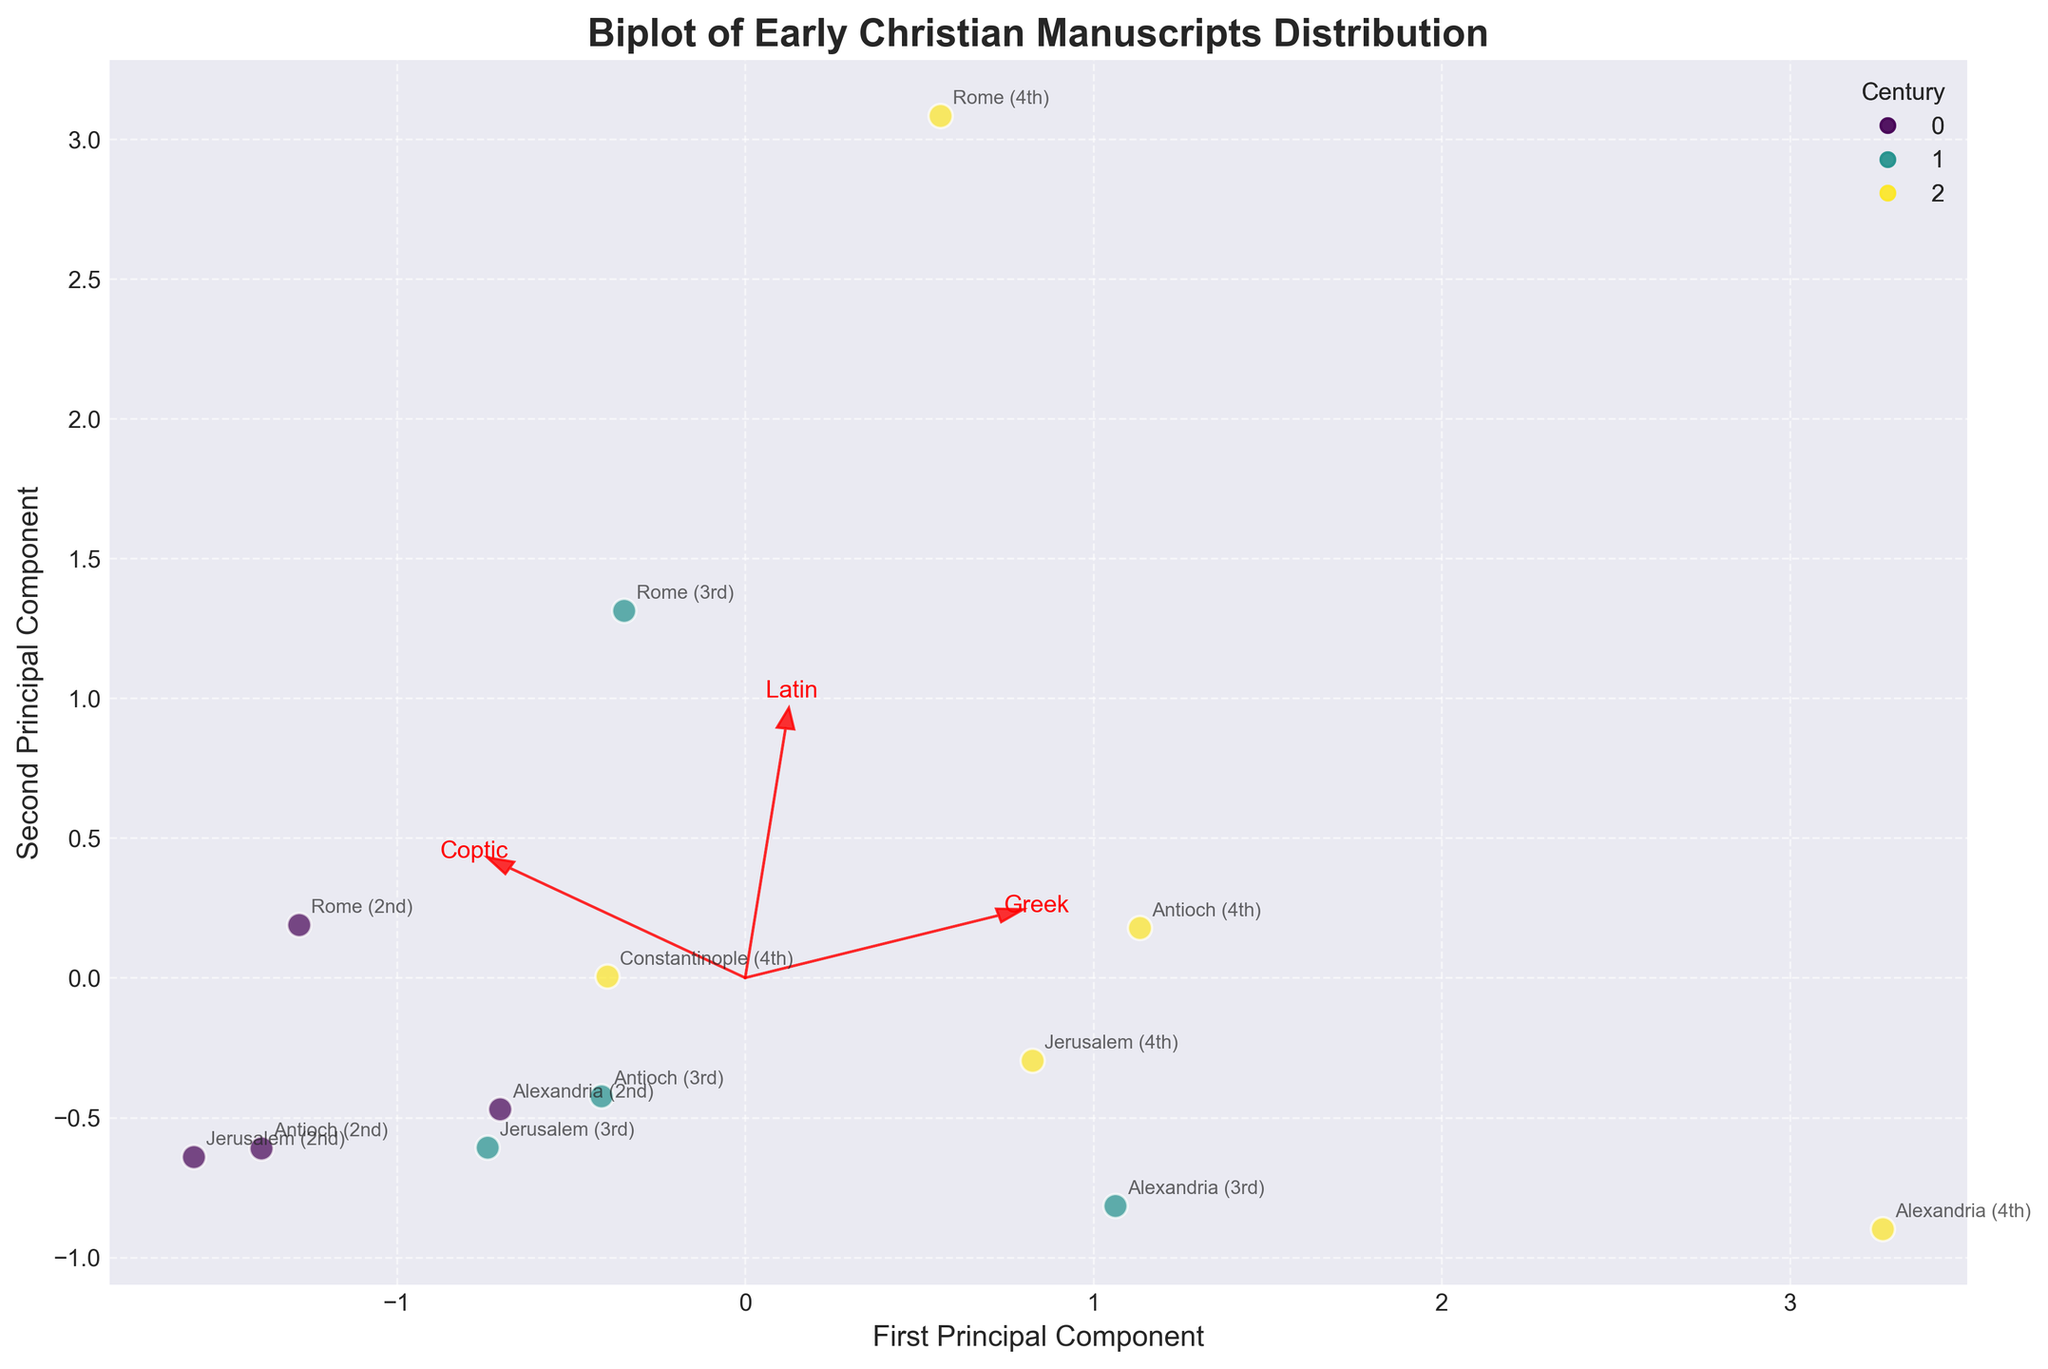How many total manuscripts are represented in the 3rd century? The figure provides information for each region's number of manuscripts in different centuries. Specifically for the 3rd century: Rome (25), Alexandria (30), Antioch (18), and Jerusalem (14). Summing these values: 25 + 30 + 18 + 14 = 87.
Answer: 87 Which region has the highest number of manuscripts in the 4th century? The figure shows the number of manuscripts in the 4th century for different regions: Rome (40), Alexandria (50), Antioch (35), Jerusalem (30), and Constantinople (20). The highest number is 50 from Alexandria.
Answer: Alexandria What language is most strongly associated with the 2nd component in the biplot? The biplot arrows indicate the direction and strength of association for each language: Greek, Latin, and Coptic. The arrow that aligns closest with the second principal component reflects the strongest association. In this case, the Latin arrow is most aligned with the 2nd component.
Answer: Latin Which regions have data points that are closer to the origin in the biplot? Points near the origin indicate average values in the standardized data. Visual inspection of the plot shows that Jerusalem (2nd century), Antioch (2nd century), and Constantinople (4th century) appear closer to the origin.
Answer: Jerusalem (2nd century), Antioch (2nd century), Constantinople (4th century) Which century exhibits the greatest variety in manuscript counts across different regions? Variety can be interpreted through the spread of data points within each century. The 3rd century shows more dispersed points in the biplot, indicating higher variability in manuscript counts.
Answer: 3rd century How do the manuscript counts in Alexandria compare between the 2nd and 3rd centuries? For Alexandria, the figure shows 15 manuscripts in the 2nd century and 30 manuscripts in the 3rd century. Comparatively, the 3rd century has twice the manuscript counts of the 2nd century.
Answer: Alexandria experienced an increase from 15 to 30 Which language has the smallest influence on the first principal component? In a biplot, the influence is depicted by the length of the arrows in the direction of the components. The Coptic arrow appears shortest relative to the first principal component, indicating its smallest influence.
Answer: Coptic What is the predominant language in manuscripts from Antioch in the 4th century? The biplot color coding and manual annotation show that Antioch in the 4th century has 28 Greek, 4 Latin, and 3 Coptic manuscripts. The predominant language is Greek.
Answer: Greek 